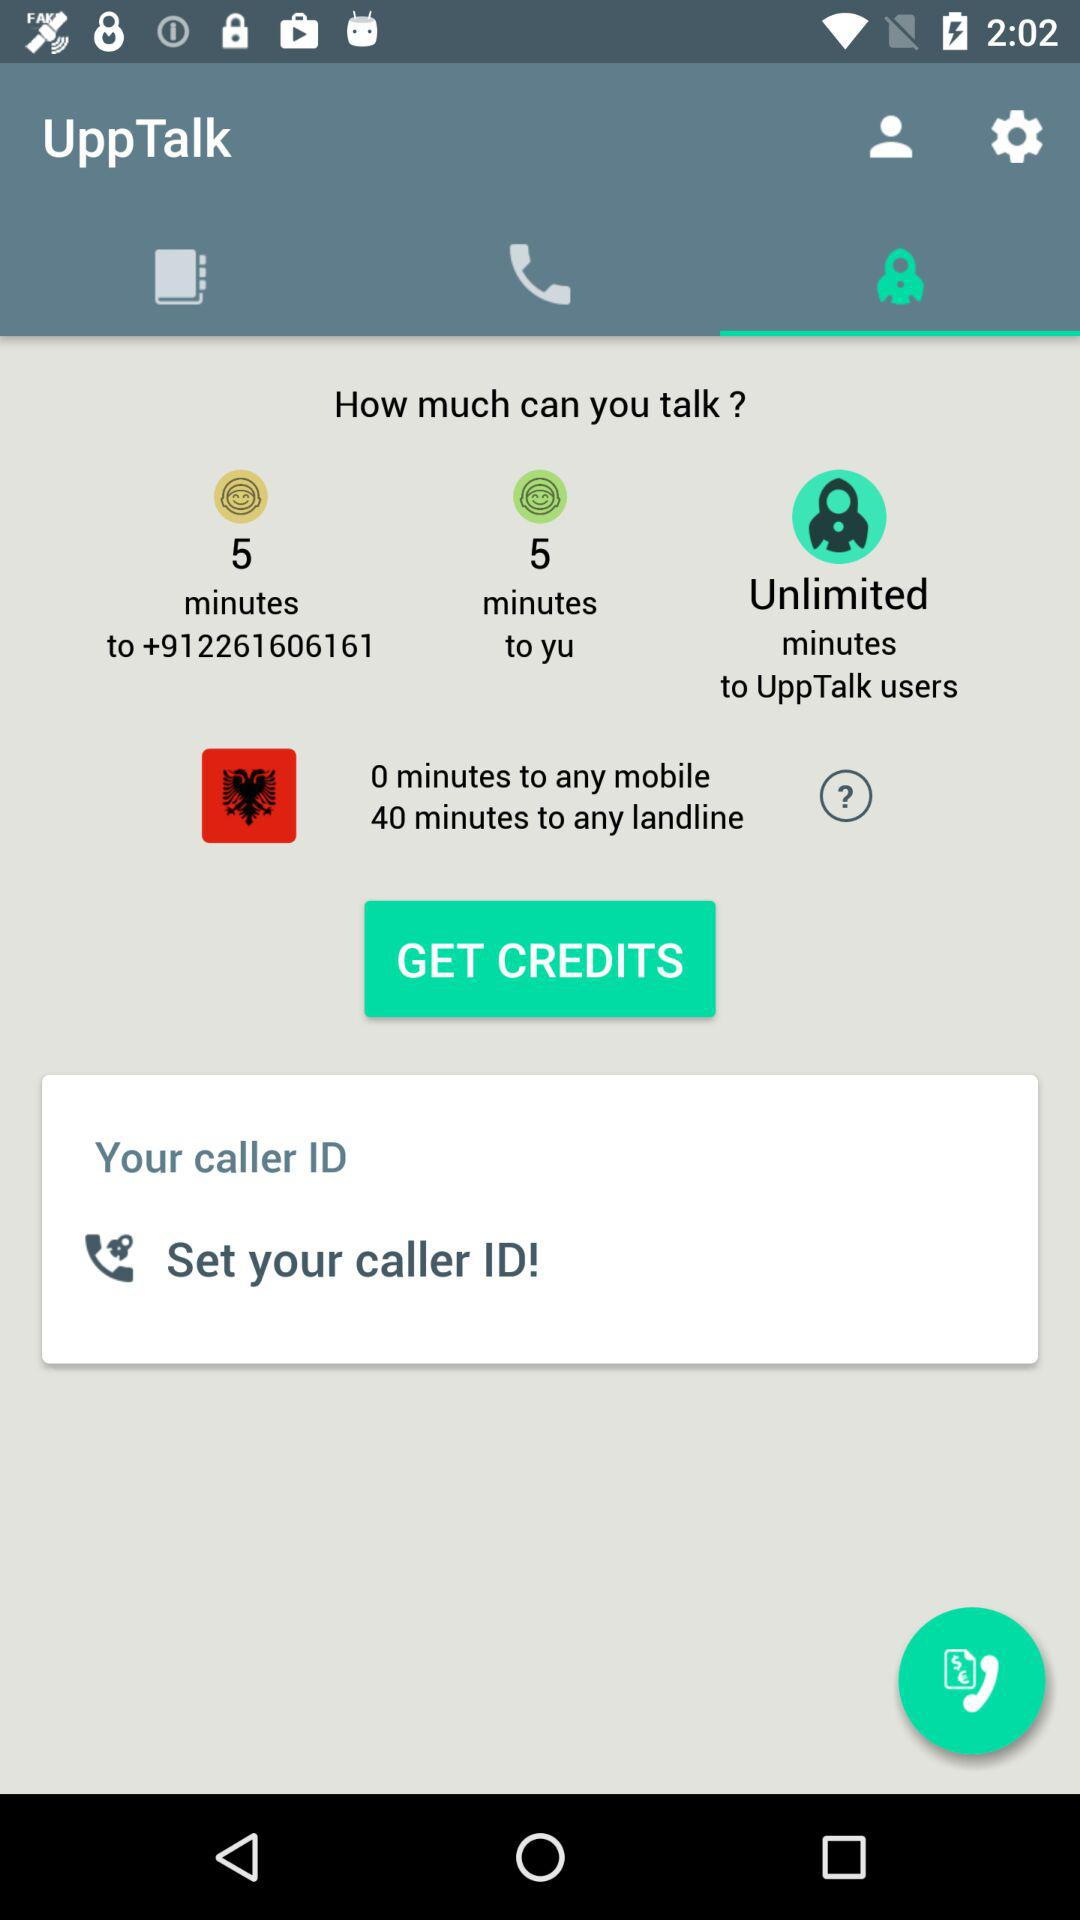How many minutes can we talk to a landline user? You can talk to a landline user for 40 minutes. 